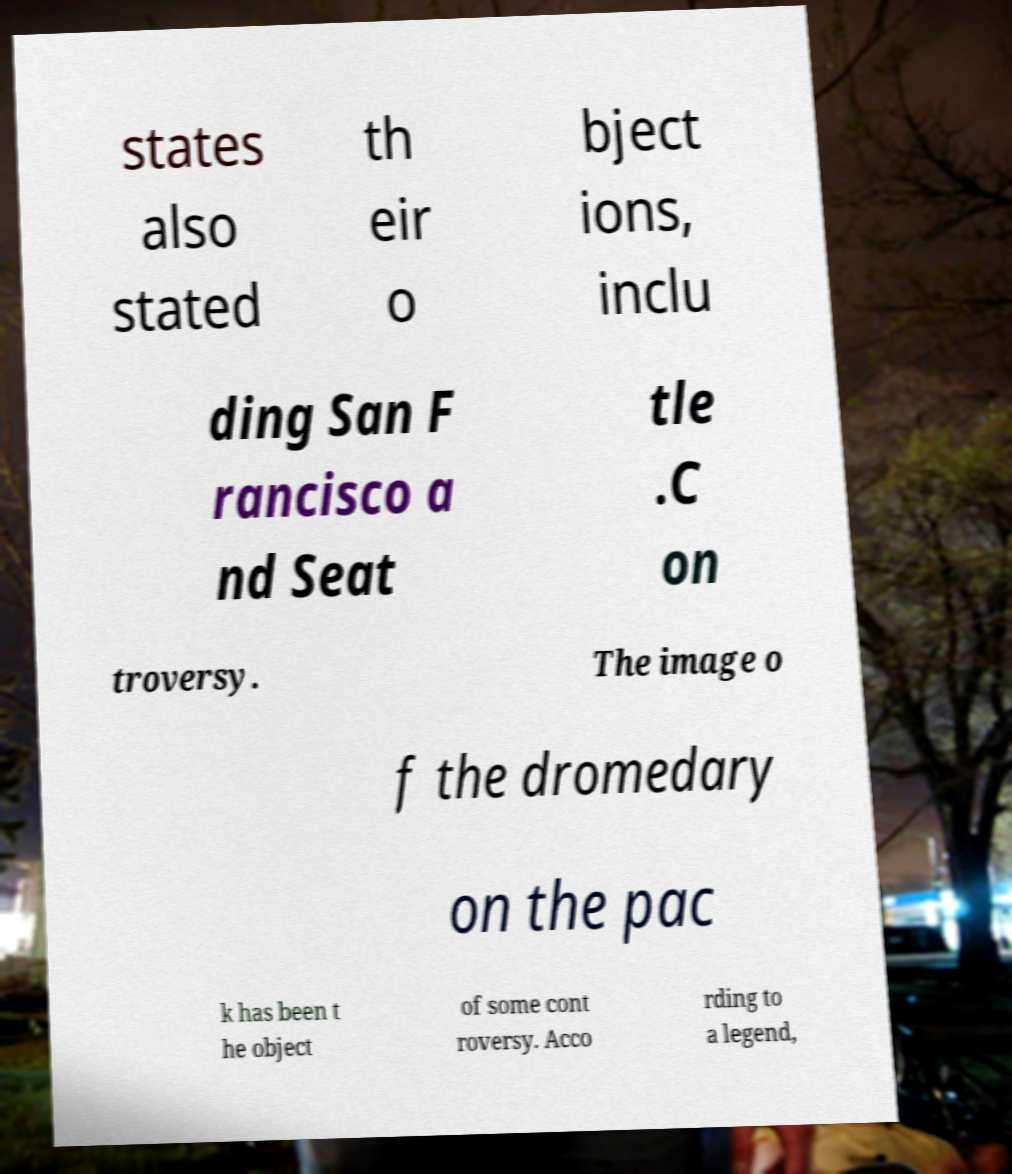There's text embedded in this image that I need extracted. Can you transcribe it verbatim? states also stated th eir o bject ions, inclu ding San F rancisco a nd Seat tle .C on troversy. The image o f the dromedary on the pac k has been t he object of some cont roversy. Acco rding to a legend, 